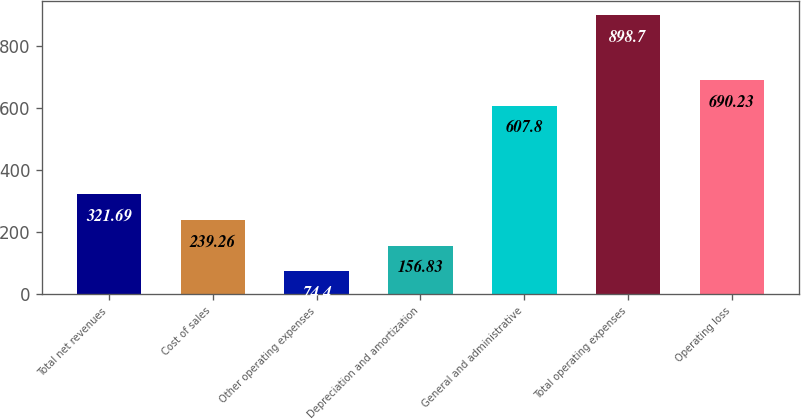Convert chart. <chart><loc_0><loc_0><loc_500><loc_500><bar_chart><fcel>Total net revenues<fcel>Cost of sales<fcel>Other operating expenses<fcel>Depreciation and amortization<fcel>General and administrative<fcel>Total operating expenses<fcel>Operating loss<nl><fcel>321.69<fcel>239.26<fcel>74.4<fcel>156.83<fcel>607.8<fcel>898.7<fcel>690.23<nl></chart> 